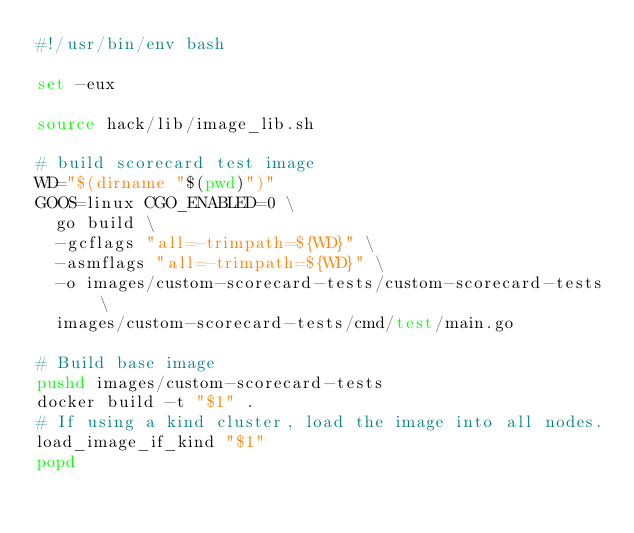<code> <loc_0><loc_0><loc_500><loc_500><_Bash_>#!/usr/bin/env bash

set -eux

source hack/lib/image_lib.sh

# build scorecard test image
WD="$(dirname "$(pwd)")"
GOOS=linux CGO_ENABLED=0 \
  go build \
  -gcflags "all=-trimpath=${WD}" \
  -asmflags "all=-trimpath=${WD}" \
  -o images/custom-scorecard-tests/custom-scorecard-tests \
  images/custom-scorecard-tests/cmd/test/main.go

# Build base image
pushd images/custom-scorecard-tests
docker build -t "$1" .
# If using a kind cluster, load the image into all nodes.
load_image_if_kind "$1"
popd
</code> 